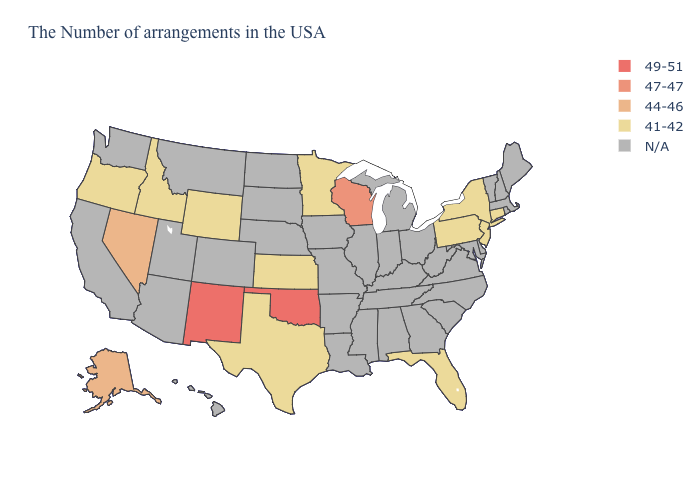What is the highest value in the USA?
Concise answer only. 49-51. What is the value of Indiana?
Quick response, please. N/A. What is the value of Alaska?
Keep it brief. 44-46. Name the states that have a value in the range 47-47?
Write a very short answer. Wisconsin. What is the value of Illinois?
Concise answer only. N/A. What is the lowest value in states that border Montana?
Short answer required. 41-42. Name the states that have a value in the range 47-47?
Quick response, please. Wisconsin. Among the states that border Rhode Island , which have the lowest value?
Write a very short answer. Connecticut. Which states have the highest value in the USA?
Write a very short answer. Oklahoma, New Mexico. Which states have the lowest value in the South?
Short answer required. Florida, Texas. Is the legend a continuous bar?
Concise answer only. No. What is the value of New Jersey?
Concise answer only. 41-42. What is the lowest value in the MidWest?
Be succinct. 41-42. What is the lowest value in the South?
Give a very brief answer. 41-42. 